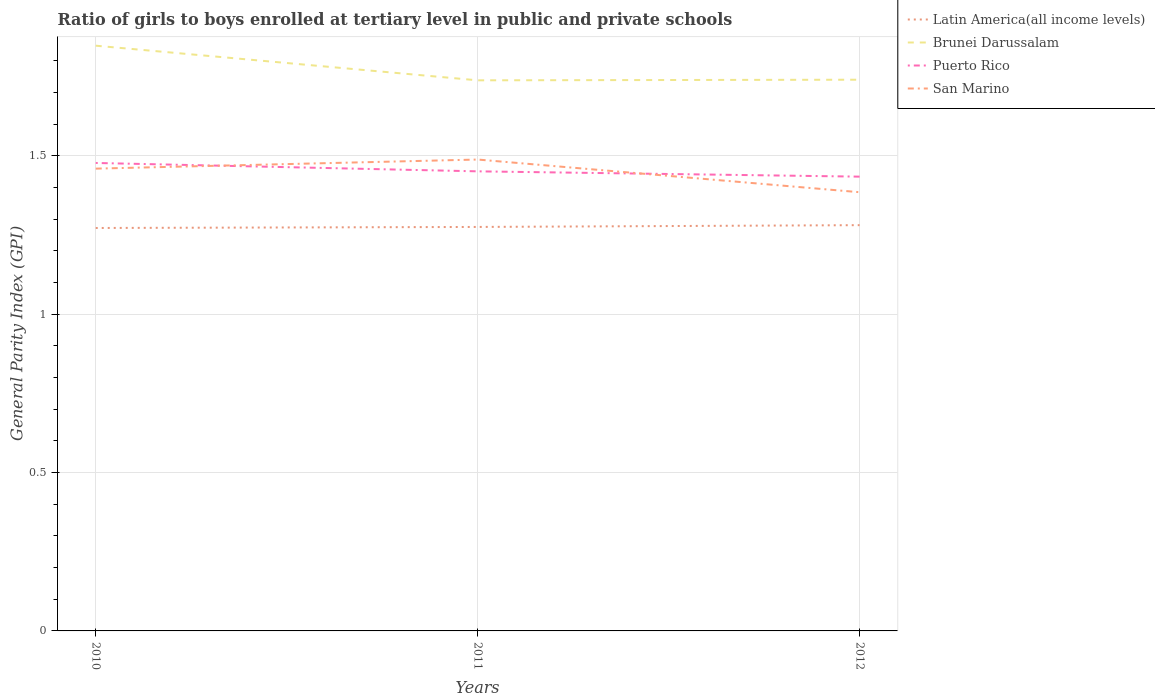Across all years, what is the maximum general parity index in Latin America(all income levels)?
Your answer should be compact. 1.27. In which year was the general parity index in Latin America(all income levels) maximum?
Give a very brief answer. 2010. What is the total general parity index in San Marino in the graph?
Offer a very short reply. 0.07. What is the difference between the highest and the second highest general parity index in Puerto Rico?
Your answer should be very brief. 0.04. What is the difference between the highest and the lowest general parity index in San Marino?
Keep it short and to the point. 2. Is the general parity index in Puerto Rico strictly greater than the general parity index in San Marino over the years?
Offer a terse response. No. What is the difference between two consecutive major ticks on the Y-axis?
Offer a terse response. 0.5. Are the values on the major ticks of Y-axis written in scientific E-notation?
Your answer should be compact. No. Does the graph contain any zero values?
Your answer should be very brief. No. What is the title of the graph?
Give a very brief answer. Ratio of girls to boys enrolled at tertiary level in public and private schools. What is the label or title of the Y-axis?
Give a very brief answer. General Parity Index (GPI). What is the General Parity Index (GPI) of Latin America(all income levels) in 2010?
Your answer should be compact. 1.27. What is the General Parity Index (GPI) in Brunei Darussalam in 2010?
Your answer should be compact. 1.85. What is the General Parity Index (GPI) in Puerto Rico in 2010?
Give a very brief answer. 1.48. What is the General Parity Index (GPI) in San Marino in 2010?
Keep it short and to the point. 1.46. What is the General Parity Index (GPI) of Latin America(all income levels) in 2011?
Give a very brief answer. 1.28. What is the General Parity Index (GPI) in Brunei Darussalam in 2011?
Ensure brevity in your answer.  1.74. What is the General Parity Index (GPI) in Puerto Rico in 2011?
Ensure brevity in your answer.  1.45. What is the General Parity Index (GPI) in San Marino in 2011?
Your response must be concise. 1.49. What is the General Parity Index (GPI) of Latin America(all income levels) in 2012?
Provide a short and direct response. 1.28. What is the General Parity Index (GPI) in Brunei Darussalam in 2012?
Offer a very short reply. 1.74. What is the General Parity Index (GPI) of Puerto Rico in 2012?
Give a very brief answer. 1.43. What is the General Parity Index (GPI) of San Marino in 2012?
Offer a very short reply. 1.38. Across all years, what is the maximum General Parity Index (GPI) of Latin America(all income levels)?
Make the answer very short. 1.28. Across all years, what is the maximum General Parity Index (GPI) of Brunei Darussalam?
Offer a very short reply. 1.85. Across all years, what is the maximum General Parity Index (GPI) of Puerto Rico?
Your answer should be compact. 1.48. Across all years, what is the maximum General Parity Index (GPI) of San Marino?
Make the answer very short. 1.49. Across all years, what is the minimum General Parity Index (GPI) of Latin America(all income levels)?
Offer a terse response. 1.27. Across all years, what is the minimum General Parity Index (GPI) in Brunei Darussalam?
Ensure brevity in your answer.  1.74. Across all years, what is the minimum General Parity Index (GPI) in Puerto Rico?
Your answer should be very brief. 1.43. Across all years, what is the minimum General Parity Index (GPI) of San Marino?
Provide a succinct answer. 1.38. What is the total General Parity Index (GPI) in Latin America(all income levels) in the graph?
Your response must be concise. 3.83. What is the total General Parity Index (GPI) in Brunei Darussalam in the graph?
Give a very brief answer. 5.33. What is the total General Parity Index (GPI) of Puerto Rico in the graph?
Provide a short and direct response. 4.36. What is the total General Parity Index (GPI) of San Marino in the graph?
Your answer should be very brief. 4.33. What is the difference between the General Parity Index (GPI) in Latin America(all income levels) in 2010 and that in 2011?
Give a very brief answer. -0. What is the difference between the General Parity Index (GPI) of Brunei Darussalam in 2010 and that in 2011?
Your response must be concise. 0.11. What is the difference between the General Parity Index (GPI) of Puerto Rico in 2010 and that in 2011?
Provide a succinct answer. 0.03. What is the difference between the General Parity Index (GPI) of San Marino in 2010 and that in 2011?
Give a very brief answer. -0.03. What is the difference between the General Parity Index (GPI) in Latin America(all income levels) in 2010 and that in 2012?
Provide a succinct answer. -0.01. What is the difference between the General Parity Index (GPI) of Brunei Darussalam in 2010 and that in 2012?
Make the answer very short. 0.11. What is the difference between the General Parity Index (GPI) in Puerto Rico in 2010 and that in 2012?
Ensure brevity in your answer.  0.04. What is the difference between the General Parity Index (GPI) in San Marino in 2010 and that in 2012?
Ensure brevity in your answer.  0.07. What is the difference between the General Parity Index (GPI) of Latin America(all income levels) in 2011 and that in 2012?
Make the answer very short. -0.01. What is the difference between the General Parity Index (GPI) of Brunei Darussalam in 2011 and that in 2012?
Make the answer very short. -0. What is the difference between the General Parity Index (GPI) in Puerto Rico in 2011 and that in 2012?
Provide a short and direct response. 0.02. What is the difference between the General Parity Index (GPI) in San Marino in 2011 and that in 2012?
Make the answer very short. 0.1. What is the difference between the General Parity Index (GPI) in Latin America(all income levels) in 2010 and the General Parity Index (GPI) in Brunei Darussalam in 2011?
Provide a short and direct response. -0.47. What is the difference between the General Parity Index (GPI) in Latin America(all income levels) in 2010 and the General Parity Index (GPI) in Puerto Rico in 2011?
Your answer should be very brief. -0.18. What is the difference between the General Parity Index (GPI) of Latin America(all income levels) in 2010 and the General Parity Index (GPI) of San Marino in 2011?
Provide a succinct answer. -0.22. What is the difference between the General Parity Index (GPI) in Brunei Darussalam in 2010 and the General Parity Index (GPI) in Puerto Rico in 2011?
Make the answer very short. 0.4. What is the difference between the General Parity Index (GPI) of Brunei Darussalam in 2010 and the General Parity Index (GPI) of San Marino in 2011?
Give a very brief answer. 0.36. What is the difference between the General Parity Index (GPI) of Puerto Rico in 2010 and the General Parity Index (GPI) of San Marino in 2011?
Provide a short and direct response. -0.01. What is the difference between the General Parity Index (GPI) in Latin America(all income levels) in 2010 and the General Parity Index (GPI) in Brunei Darussalam in 2012?
Your answer should be very brief. -0.47. What is the difference between the General Parity Index (GPI) in Latin America(all income levels) in 2010 and the General Parity Index (GPI) in Puerto Rico in 2012?
Your response must be concise. -0.16. What is the difference between the General Parity Index (GPI) of Latin America(all income levels) in 2010 and the General Parity Index (GPI) of San Marino in 2012?
Provide a succinct answer. -0.11. What is the difference between the General Parity Index (GPI) of Brunei Darussalam in 2010 and the General Parity Index (GPI) of Puerto Rico in 2012?
Provide a succinct answer. 0.41. What is the difference between the General Parity Index (GPI) of Brunei Darussalam in 2010 and the General Parity Index (GPI) of San Marino in 2012?
Keep it short and to the point. 0.46. What is the difference between the General Parity Index (GPI) of Puerto Rico in 2010 and the General Parity Index (GPI) of San Marino in 2012?
Ensure brevity in your answer.  0.09. What is the difference between the General Parity Index (GPI) in Latin America(all income levels) in 2011 and the General Parity Index (GPI) in Brunei Darussalam in 2012?
Your response must be concise. -0.46. What is the difference between the General Parity Index (GPI) in Latin America(all income levels) in 2011 and the General Parity Index (GPI) in Puerto Rico in 2012?
Your answer should be very brief. -0.16. What is the difference between the General Parity Index (GPI) of Latin America(all income levels) in 2011 and the General Parity Index (GPI) of San Marino in 2012?
Make the answer very short. -0.11. What is the difference between the General Parity Index (GPI) of Brunei Darussalam in 2011 and the General Parity Index (GPI) of Puerto Rico in 2012?
Your response must be concise. 0.3. What is the difference between the General Parity Index (GPI) of Brunei Darussalam in 2011 and the General Parity Index (GPI) of San Marino in 2012?
Provide a succinct answer. 0.35. What is the difference between the General Parity Index (GPI) in Puerto Rico in 2011 and the General Parity Index (GPI) in San Marino in 2012?
Provide a succinct answer. 0.07. What is the average General Parity Index (GPI) in Latin America(all income levels) per year?
Make the answer very short. 1.28. What is the average General Parity Index (GPI) in Brunei Darussalam per year?
Offer a very short reply. 1.78. What is the average General Parity Index (GPI) in Puerto Rico per year?
Your answer should be compact. 1.45. What is the average General Parity Index (GPI) of San Marino per year?
Make the answer very short. 1.44. In the year 2010, what is the difference between the General Parity Index (GPI) of Latin America(all income levels) and General Parity Index (GPI) of Brunei Darussalam?
Give a very brief answer. -0.58. In the year 2010, what is the difference between the General Parity Index (GPI) of Latin America(all income levels) and General Parity Index (GPI) of Puerto Rico?
Your answer should be very brief. -0.21. In the year 2010, what is the difference between the General Parity Index (GPI) of Latin America(all income levels) and General Parity Index (GPI) of San Marino?
Give a very brief answer. -0.19. In the year 2010, what is the difference between the General Parity Index (GPI) in Brunei Darussalam and General Parity Index (GPI) in Puerto Rico?
Make the answer very short. 0.37. In the year 2010, what is the difference between the General Parity Index (GPI) in Brunei Darussalam and General Parity Index (GPI) in San Marino?
Give a very brief answer. 0.39. In the year 2010, what is the difference between the General Parity Index (GPI) in Puerto Rico and General Parity Index (GPI) in San Marino?
Offer a terse response. 0.02. In the year 2011, what is the difference between the General Parity Index (GPI) in Latin America(all income levels) and General Parity Index (GPI) in Brunei Darussalam?
Ensure brevity in your answer.  -0.46. In the year 2011, what is the difference between the General Parity Index (GPI) of Latin America(all income levels) and General Parity Index (GPI) of Puerto Rico?
Keep it short and to the point. -0.18. In the year 2011, what is the difference between the General Parity Index (GPI) in Latin America(all income levels) and General Parity Index (GPI) in San Marino?
Your answer should be very brief. -0.21. In the year 2011, what is the difference between the General Parity Index (GPI) of Brunei Darussalam and General Parity Index (GPI) of Puerto Rico?
Offer a very short reply. 0.29. In the year 2011, what is the difference between the General Parity Index (GPI) of Brunei Darussalam and General Parity Index (GPI) of San Marino?
Give a very brief answer. 0.25. In the year 2011, what is the difference between the General Parity Index (GPI) of Puerto Rico and General Parity Index (GPI) of San Marino?
Make the answer very short. -0.04. In the year 2012, what is the difference between the General Parity Index (GPI) of Latin America(all income levels) and General Parity Index (GPI) of Brunei Darussalam?
Offer a terse response. -0.46. In the year 2012, what is the difference between the General Parity Index (GPI) of Latin America(all income levels) and General Parity Index (GPI) of Puerto Rico?
Offer a very short reply. -0.15. In the year 2012, what is the difference between the General Parity Index (GPI) of Latin America(all income levels) and General Parity Index (GPI) of San Marino?
Make the answer very short. -0.1. In the year 2012, what is the difference between the General Parity Index (GPI) of Brunei Darussalam and General Parity Index (GPI) of Puerto Rico?
Your answer should be very brief. 0.31. In the year 2012, what is the difference between the General Parity Index (GPI) of Brunei Darussalam and General Parity Index (GPI) of San Marino?
Your response must be concise. 0.36. In the year 2012, what is the difference between the General Parity Index (GPI) of Puerto Rico and General Parity Index (GPI) of San Marino?
Keep it short and to the point. 0.05. What is the ratio of the General Parity Index (GPI) of Latin America(all income levels) in 2010 to that in 2011?
Offer a very short reply. 1. What is the ratio of the General Parity Index (GPI) in Brunei Darussalam in 2010 to that in 2011?
Provide a short and direct response. 1.06. What is the ratio of the General Parity Index (GPI) in Puerto Rico in 2010 to that in 2011?
Keep it short and to the point. 1.02. What is the ratio of the General Parity Index (GPI) in San Marino in 2010 to that in 2011?
Keep it short and to the point. 0.98. What is the ratio of the General Parity Index (GPI) in Latin America(all income levels) in 2010 to that in 2012?
Your answer should be compact. 0.99. What is the ratio of the General Parity Index (GPI) in Brunei Darussalam in 2010 to that in 2012?
Your answer should be very brief. 1.06. What is the ratio of the General Parity Index (GPI) in Puerto Rico in 2010 to that in 2012?
Provide a succinct answer. 1.03. What is the ratio of the General Parity Index (GPI) in San Marino in 2010 to that in 2012?
Provide a succinct answer. 1.05. What is the ratio of the General Parity Index (GPI) of Puerto Rico in 2011 to that in 2012?
Offer a very short reply. 1.01. What is the ratio of the General Parity Index (GPI) in San Marino in 2011 to that in 2012?
Make the answer very short. 1.07. What is the difference between the highest and the second highest General Parity Index (GPI) in Latin America(all income levels)?
Provide a short and direct response. 0.01. What is the difference between the highest and the second highest General Parity Index (GPI) in Brunei Darussalam?
Provide a short and direct response. 0.11. What is the difference between the highest and the second highest General Parity Index (GPI) of Puerto Rico?
Offer a very short reply. 0.03. What is the difference between the highest and the second highest General Parity Index (GPI) in San Marino?
Provide a short and direct response. 0.03. What is the difference between the highest and the lowest General Parity Index (GPI) in Latin America(all income levels)?
Make the answer very short. 0.01. What is the difference between the highest and the lowest General Parity Index (GPI) in Brunei Darussalam?
Offer a terse response. 0.11. What is the difference between the highest and the lowest General Parity Index (GPI) in Puerto Rico?
Offer a terse response. 0.04. What is the difference between the highest and the lowest General Parity Index (GPI) of San Marino?
Give a very brief answer. 0.1. 